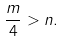Convert formula to latex. <formula><loc_0><loc_0><loc_500><loc_500>\frac { m } { 4 } > n .</formula> 